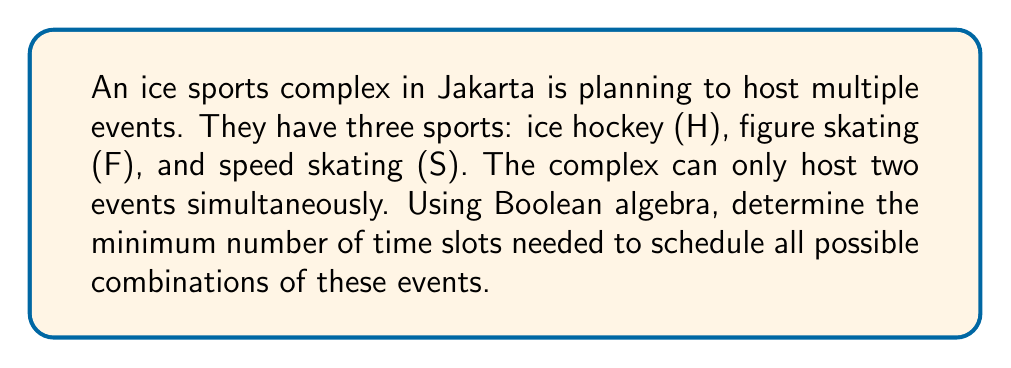Show me your answer to this math problem. Let's approach this step-by-step using Boolean algebra:

1) First, we need to list all possible combinations of events:
   - H alone
   - F alone
   - S alone
   - H and F together
   - H and S together
   - F and S together

2) We can represent each combination as a Boolean expression:
   $$H\bar{F}\bar{S} + \bar{H}F\bar{S} + \bar{H}\bar{F}S + HF\bar{S} + H\bar{F}S + \bar{H}FS$$

3) This expression represents all possible event combinations. Our goal is to minimize the number of terms, which will correspond to the minimum number of time slots needed.

4) We can simplify this expression using Boolean algebra laws:
   $$H\bar{F}\bar{S} + \bar{H}F\bar{S} + \bar{H}\bar{F}S + HF\bar{S} + H\bar{F}S + \bar{H}FS$$
   $$= H\bar{S}(\bar{F} + F) + \bar{H}S(\bar{F} + F) + \bar{H}\bar{S}F$$
   $$= H\bar{S} + \bar{H}S + \bar{H}\bar{S}F$$

5) This simplified expression has three terms, which means we need a minimum of three time slots to schedule all possible combinations of events.

6) These three slots correspond to:
   - H\bar{S}: Ice hockey (with or without figure skating)
   - \bar{H}S: Speed skating (with or without figure skating)
   - \bar{H}\bar{S}F: Figure skating alone
Answer: 3 time slots 